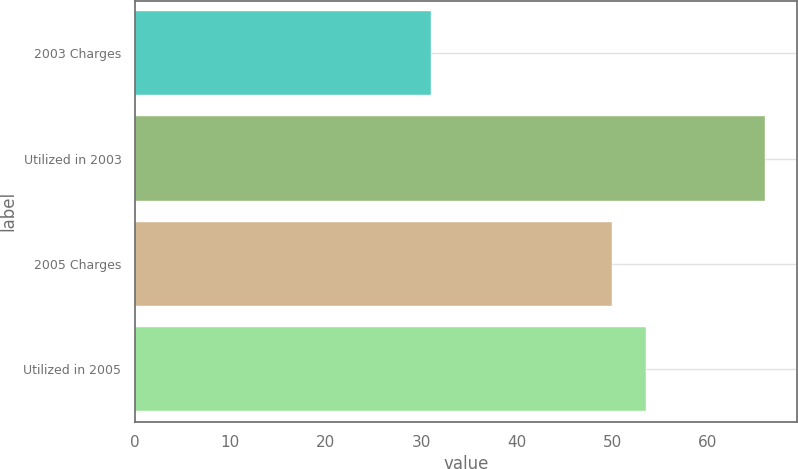Convert chart. <chart><loc_0><loc_0><loc_500><loc_500><bar_chart><fcel>2003 Charges<fcel>Utilized in 2003<fcel>2005 Charges<fcel>Utilized in 2005<nl><fcel>31<fcel>66<fcel>50<fcel>53.5<nl></chart> 